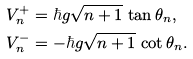<formula> <loc_0><loc_0><loc_500><loc_500>V ^ { + } _ { n } & = \hbar { g } \sqrt { n + 1 } \, \tan \theta _ { n } , \\ V ^ { - } _ { n } & = - \hbar { g } \sqrt { n + 1 } \, \cot \theta _ { n } .</formula> 